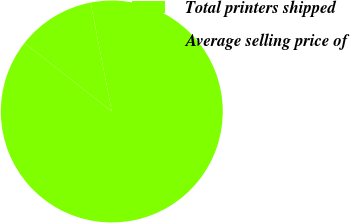Convert chart to OTSL. <chart><loc_0><loc_0><loc_500><loc_500><pie_chart><fcel>Total printers shipped<fcel>Average selling price of<nl><fcel>88.64%<fcel>11.36%<nl></chart> 